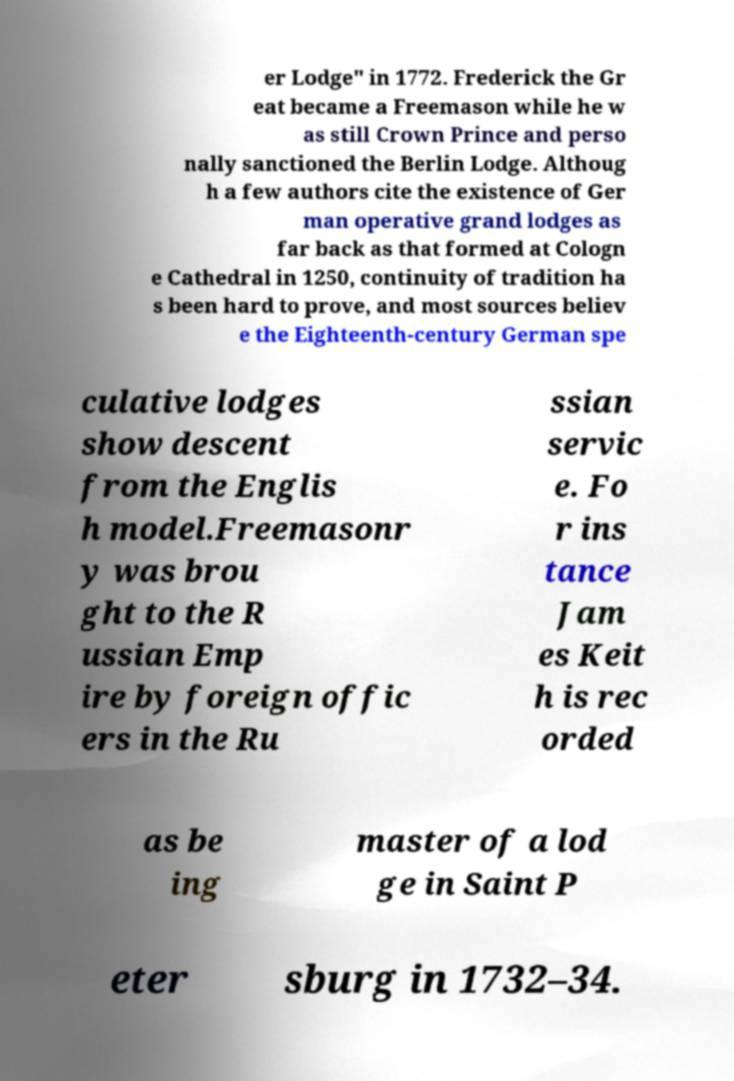I need the written content from this picture converted into text. Can you do that? er Lodge" in 1772. Frederick the Gr eat became a Freemason while he w as still Crown Prince and perso nally sanctioned the Berlin Lodge. Althoug h a few authors cite the existence of Ger man operative grand lodges as far back as that formed at Cologn e Cathedral in 1250, continuity of tradition ha s been hard to prove, and most sources believ e the Eighteenth-century German spe culative lodges show descent from the Englis h model.Freemasonr y was brou ght to the R ussian Emp ire by foreign offic ers in the Ru ssian servic e. Fo r ins tance Jam es Keit h is rec orded as be ing master of a lod ge in Saint P eter sburg in 1732–34. 